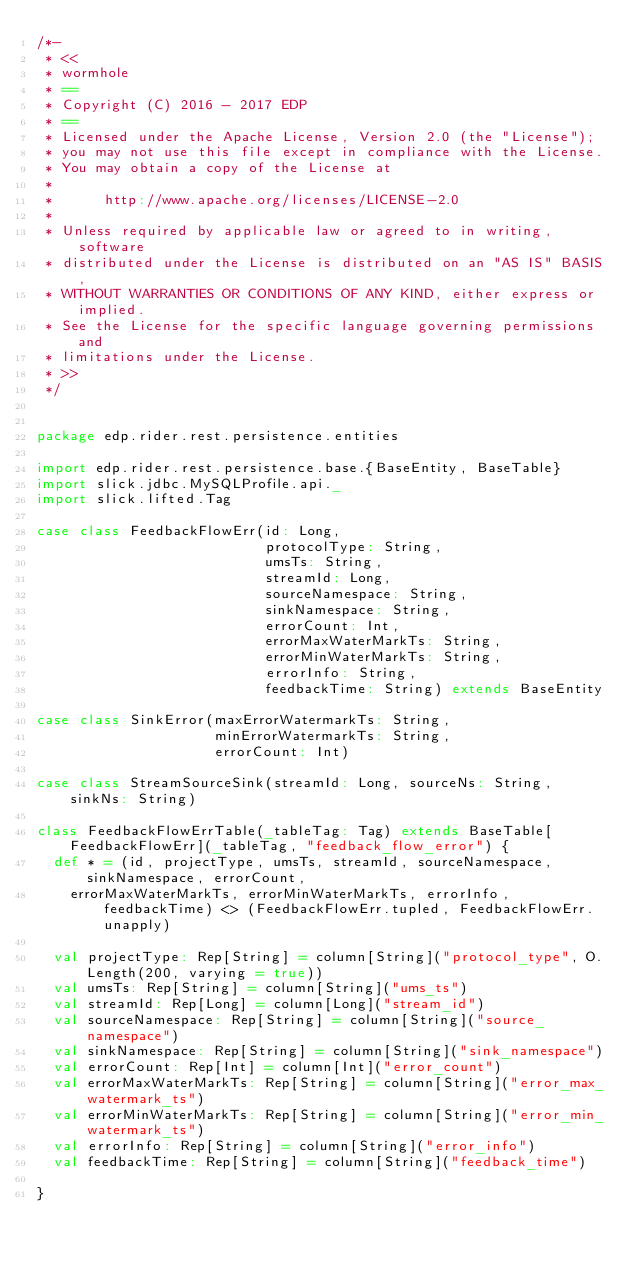<code> <loc_0><loc_0><loc_500><loc_500><_Scala_>/*-
 * <<
 * wormhole
 * ==
 * Copyright (C) 2016 - 2017 EDP
 * ==
 * Licensed under the Apache License, Version 2.0 (the "License");
 * you may not use this file except in compliance with the License.
 * You may obtain a copy of the License at
 * 
 *      http://www.apache.org/licenses/LICENSE-2.0
 * 
 * Unless required by applicable law or agreed to in writing, software
 * distributed under the License is distributed on an "AS IS" BASIS,
 * WITHOUT WARRANTIES OR CONDITIONS OF ANY KIND, either express or implied.
 * See the License for the specific language governing permissions and
 * limitations under the License.
 * >>
 */


package edp.rider.rest.persistence.entities

import edp.rider.rest.persistence.base.{BaseEntity, BaseTable}
import slick.jdbc.MySQLProfile.api._
import slick.lifted.Tag

case class FeedbackFlowErr(id: Long,
                           protocolType: String,
                           umsTs: String,
                           streamId: Long,
                           sourceNamespace: String,
                           sinkNamespace: String,
                           errorCount: Int,
                           errorMaxWaterMarkTs: String,
                           errorMinWaterMarkTs: String,
                           errorInfo: String,
                           feedbackTime: String) extends BaseEntity

case class SinkError(maxErrorWatermarkTs: String,
                     minErrorWatermarkTs: String,
                     errorCount: Int)

case class StreamSourceSink(streamId: Long, sourceNs: String, sinkNs: String)

class FeedbackFlowErrTable(_tableTag: Tag) extends BaseTable[FeedbackFlowErr](_tableTag, "feedback_flow_error") {
  def * = (id, projectType, umsTs, streamId, sourceNamespace, sinkNamespace, errorCount,
    errorMaxWaterMarkTs, errorMinWaterMarkTs, errorInfo, feedbackTime) <> (FeedbackFlowErr.tupled, FeedbackFlowErr.unapply)

  val projectType: Rep[String] = column[String]("protocol_type", O.Length(200, varying = true))
  val umsTs: Rep[String] = column[String]("ums_ts")
  val streamId: Rep[Long] = column[Long]("stream_id")
  val sourceNamespace: Rep[String] = column[String]("source_namespace")
  val sinkNamespace: Rep[String] = column[String]("sink_namespace")
  val errorCount: Rep[Int] = column[Int]("error_count")
  val errorMaxWaterMarkTs: Rep[String] = column[String]("error_max_watermark_ts")
  val errorMinWaterMarkTs: Rep[String] = column[String]("error_min_watermark_ts")
  val errorInfo: Rep[String] = column[String]("error_info")
  val feedbackTime: Rep[String] = column[String]("feedback_time")

}
</code> 